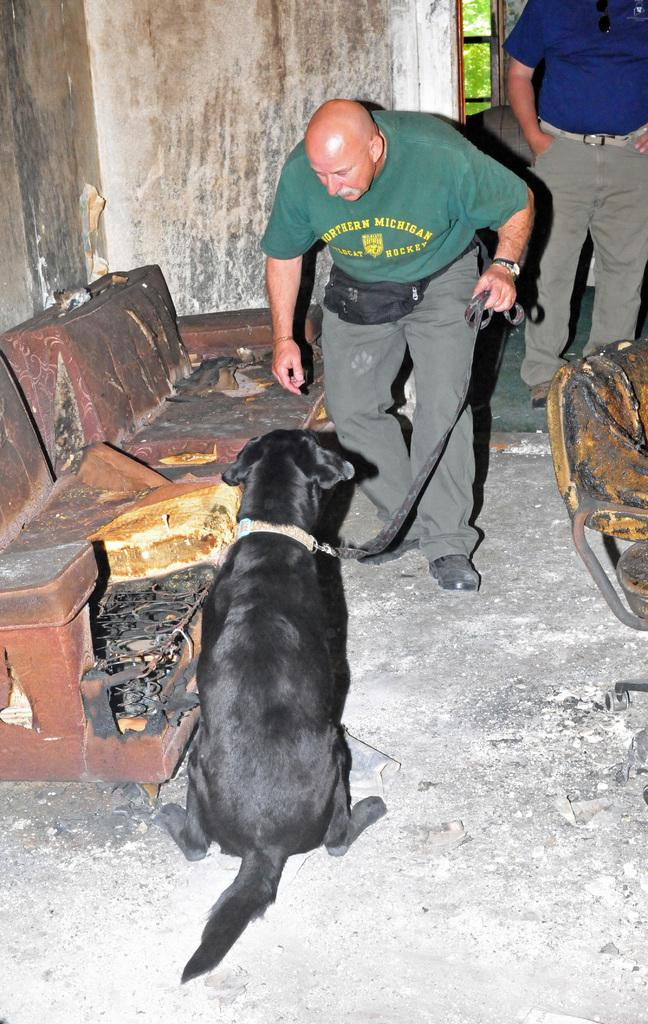How many people are in the image? There are two men standing in the image. What is the dog doing in the image? The dog is sitting on the floor in the image. What piece of furniture is on the left side of the image? There is a sofa to the left in the image. What can be seen in the background of the image? There is a tree in the background of the image. What type of apparatus is being used by the men in the image? There is no apparatus visible in the image; the men are simply standing. Can you tell me which eye of the dog is visible in the image? The image does not provide a close-up view of the dog's face, so it is not possible to determine which eye is visible. 